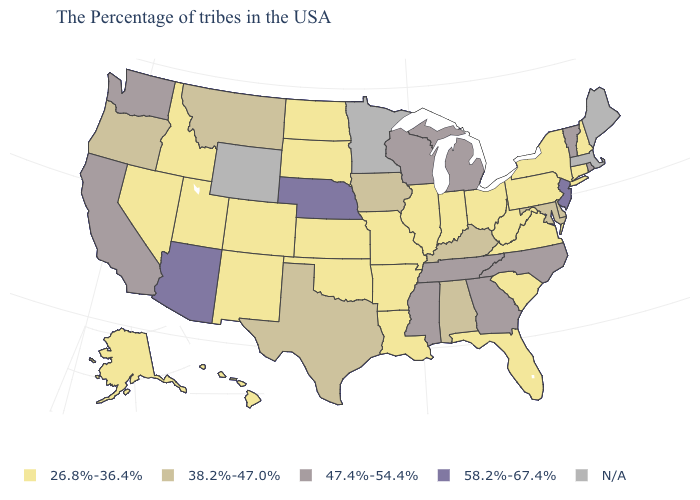What is the lowest value in the MidWest?
Concise answer only. 26.8%-36.4%. What is the value of Arkansas?
Be succinct. 26.8%-36.4%. What is the highest value in the USA?
Concise answer only. 58.2%-67.4%. What is the value of Iowa?
Concise answer only. 38.2%-47.0%. What is the value of Colorado?
Keep it brief. 26.8%-36.4%. Which states hav the highest value in the Northeast?
Quick response, please. New Jersey. What is the value of West Virginia?
Give a very brief answer. 26.8%-36.4%. Name the states that have a value in the range 58.2%-67.4%?
Concise answer only. New Jersey, Nebraska, Arizona. What is the highest value in the Northeast ?
Quick response, please. 58.2%-67.4%. Which states hav the highest value in the South?
Answer briefly. North Carolina, Georgia, Tennessee, Mississippi. Which states have the lowest value in the MidWest?
Be succinct. Ohio, Indiana, Illinois, Missouri, Kansas, South Dakota, North Dakota. What is the value of Louisiana?
Short answer required. 26.8%-36.4%. Does Alabama have the highest value in the South?
Answer briefly. No. Name the states that have a value in the range 47.4%-54.4%?
Concise answer only. Rhode Island, Vermont, North Carolina, Georgia, Michigan, Tennessee, Wisconsin, Mississippi, California, Washington. 